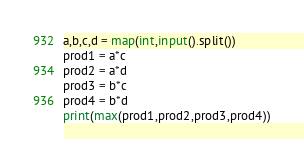<code> <loc_0><loc_0><loc_500><loc_500><_Python_>a,b,c,d = map(int,input().split())
prod1 = a*c
prod2 = a*d
prod3 = b*c
prod4 = b*d
print(max(prod1,prod2,prod3,prod4))</code> 